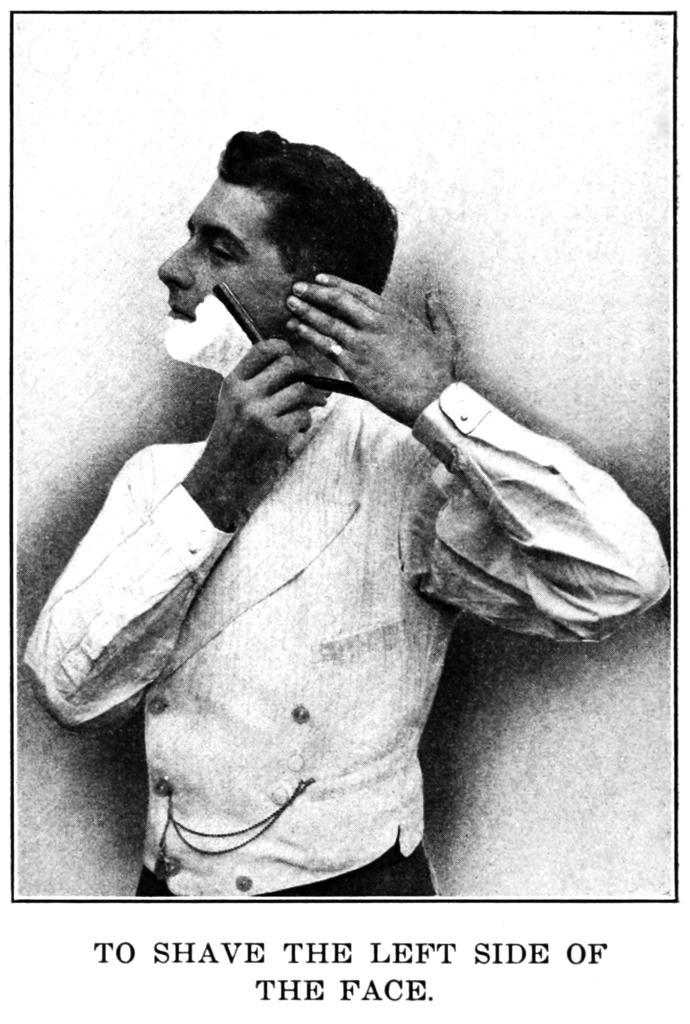Can you describe this image briefly? In this image I can see a paper. On the paper there is an image of a person holding an object, and there are some words. 